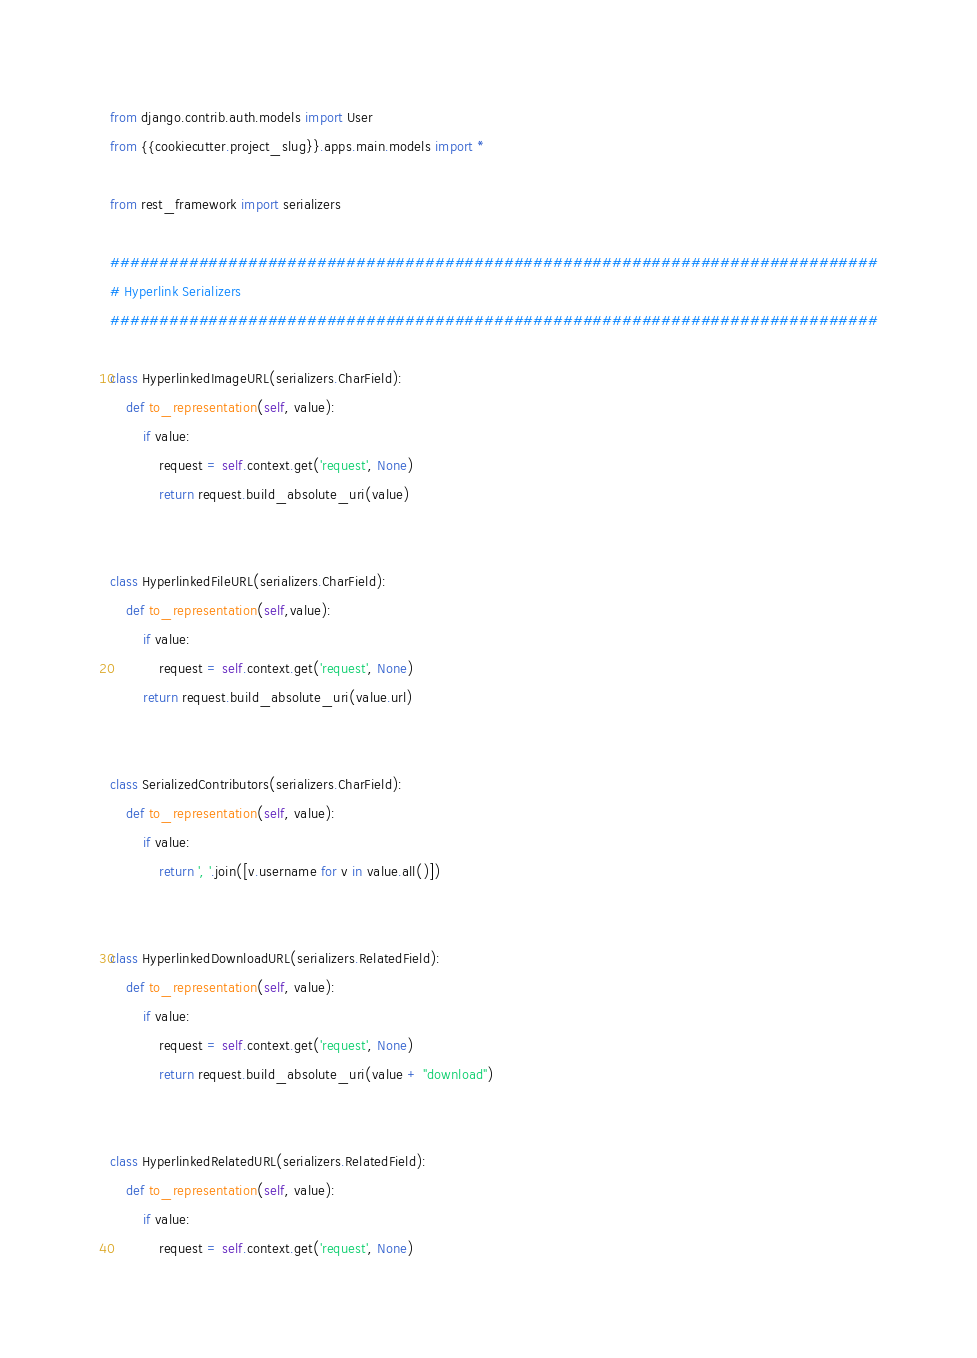<code> <loc_0><loc_0><loc_500><loc_500><_Python_>from django.contrib.auth.models import User
from {{cookiecutter.project_slug}}.apps.main.models import *

from rest_framework import serializers

##############################################################################
# Hyperlink Serializers
##############################################################################

class HyperlinkedImageURL(serializers.CharField):
    def to_representation(self, value):
        if value:
            request = self.context.get('request', None)
            return request.build_absolute_uri(value)


class HyperlinkedFileURL(serializers.CharField):
    def to_representation(self,value):
        if value:
            request = self.context.get('request', None)
        return request.build_absolute_uri(value.url)


class SerializedContributors(serializers.CharField):
    def to_representation(self, value):
        if value:
            return ', '.join([v.username for v in value.all()])


class HyperlinkedDownloadURL(serializers.RelatedField):
    def to_representation(self, value):
        if value:
            request = self.context.get('request', None)
            return request.build_absolute_uri(value + "download")


class HyperlinkedRelatedURL(serializers.RelatedField):
    def to_representation(self, value):
        if value:
            request = self.context.get('request', None)</code> 